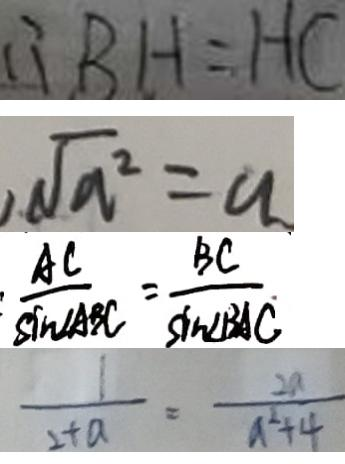<formula> <loc_0><loc_0><loc_500><loc_500>\therefore B H = H C 
 \sqrt { a ^ { 2 } } = a 
 : \frac { A C } { \sin \angle A B C } = \frac { B C } { \sin \angle B A C } 
 \frac { 1 } { 2 + a } = \frac { 2 a } { a ^ { 2 } + 4 }</formula> 